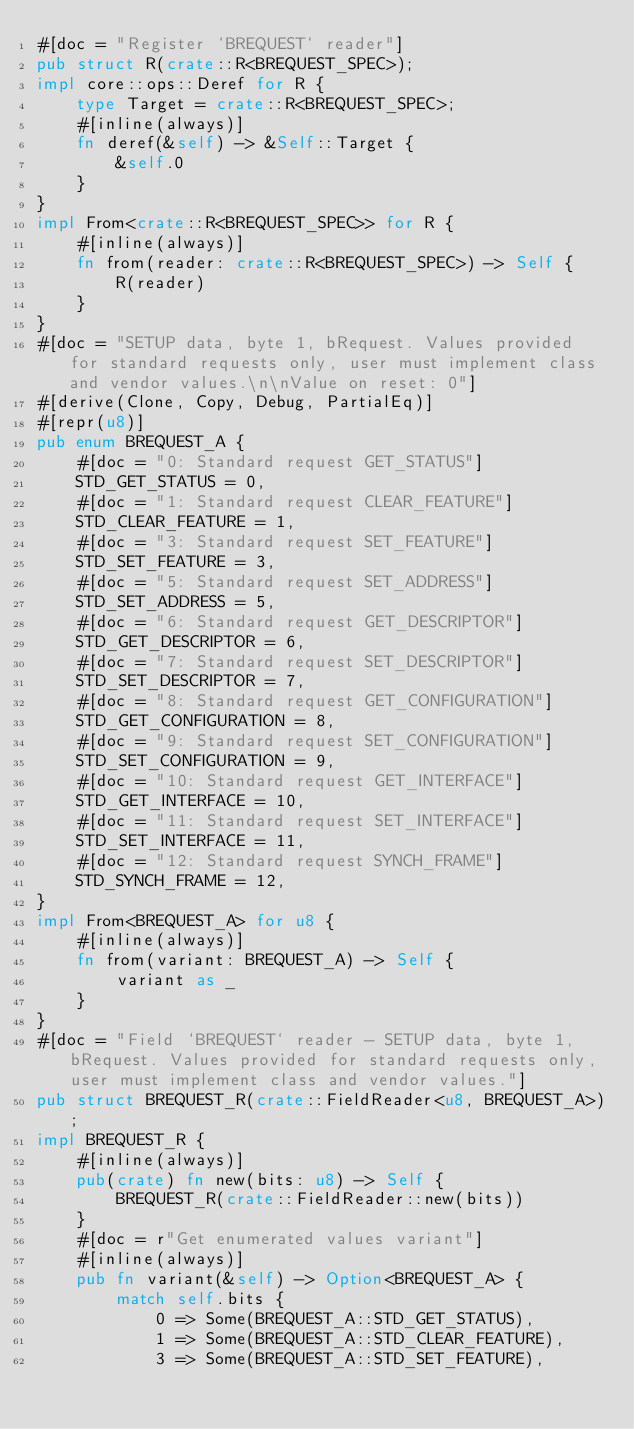<code> <loc_0><loc_0><loc_500><loc_500><_Rust_>#[doc = "Register `BREQUEST` reader"]
pub struct R(crate::R<BREQUEST_SPEC>);
impl core::ops::Deref for R {
    type Target = crate::R<BREQUEST_SPEC>;
    #[inline(always)]
    fn deref(&self) -> &Self::Target {
        &self.0
    }
}
impl From<crate::R<BREQUEST_SPEC>> for R {
    #[inline(always)]
    fn from(reader: crate::R<BREQUEST_SPEC>) -> Self {
        R(reader)
    }
}
#[doc = "SETUP data, byte 1, bRequest. Values provided for standard requests only, user must implement class and vendor values.\n\nValue on reset: 0"]
#[derive(Clone, Copy, Debug, PartialEq)]
#[repr(u8)]
pub enum BREQUEST_A {
    #[doc = "0: Standard request GET_STATUS"]
    STD_GET_STATUS = 0,
    #[doc = "1: Standard request CLEAR_FEATURE"]
    STD_CLEAR_FEATURE = 1,
    #[doc = "3: Standard request SET_FEATURE"]
    STD_SET_FEATURE = 3,
    #[doc = "5: Standard request SET_ADDRESS"]
    STD_SET_ADDRESS = 5,
    #[doc = "6: Standard request GET_DESCRIPTOR"]
    STD_GET_DESCRIPTOR = 6,
    #[doc = "7: Standard request SET_DESCRIPTOR"]
    STD_SET_DESCRIPTOR = 7,
    #[doc = "8: Standard request GET_CONFIGURATION"]
    STD_GET_CONFIGURATION = 8,
    #[doc = "9: Standard request SET_CONFIGURATION"]
    STD_SET_CONFIGURATION = 9,
    #[doc = "10: Standard request GET_INTERFACE"]
    STD_GET_INTERFACE = 10,
    #[doc = "11: Standard request SET_INTERFACE"]
    STD_SET_INTERFACE = 11,
    #[doc = "12: Standard request SYNCH_FRAME"]
    STD_SYNCH_FRAME = 12,
}
impl From<BREQUEST_A> for u8 {
    #[inline(always)]
    fn from(variant: BREQUEST_A) -> Self {
        variant as _
    }
}
#[doc = "Field `BREQUEST` reader - SETUP data, byte 1, bRequest. Values provided for standard requests only, user must implement class and vendor values."]
pub struct BREQUEST_R(crate::FieldReader<u8, BREQUEST_A>);
impl BREQUEST_R {
    #[inline(always)]
    pub(crate) fn new(bits: u8) -> Self {
        BREQUEST_R(crate::FieldReader::new(bits))
    }
    #[doc = r"Get enumerated values variant"]
    #[inline(always)]
    pub fn variant(&self) -> Option<BREQUEST_A> {
        match self.bits {
            0 => Some(BREQUEST_A::STD_GET_STATUS),
            1 => Some(BREQUEST_A::STD_CLEAR_FEATURE),
            3 => Some(BREQUEST_A::STD_SET_FEATURE),</code> 